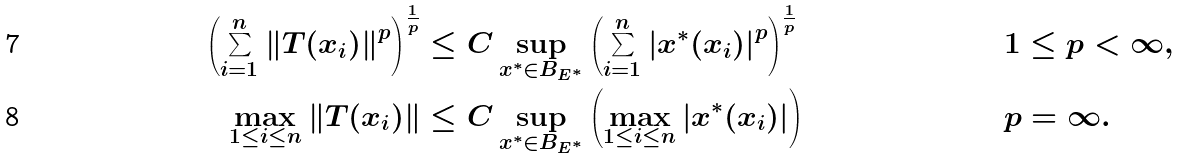<formula> <loc_0><loc_0><loc_500><loc_500>\left ( \sum _ { i = 1 } ^ { n } \left \| T ( x _ { i } ) \right \| ^ { p } \right ) ^ { \frac { 1 } { p } } & \leq C \sup _ { x ^ { * } \in B _ { E ^ { * } } } \left ( \sum _ { i = 1 } ^ { n } \left | x ^ { * } ( x _ { i } ) \right | ^ { p } \right ) ^ { \frac { 1 } { p } } & & 1 \leq p < \infty , \\ \max _ { 1 \leq i \leq n } \left \| T ( x _ { i } ) \right \| & \leq C \sup _ { x ^ { * } \in B _ { E ^ { * } } } \left ( \max _ { 1 \leq i \leq n } \left | x ^ { * } ( x _ { i } ) \right | \right ) & & p = \infty .</formula> 